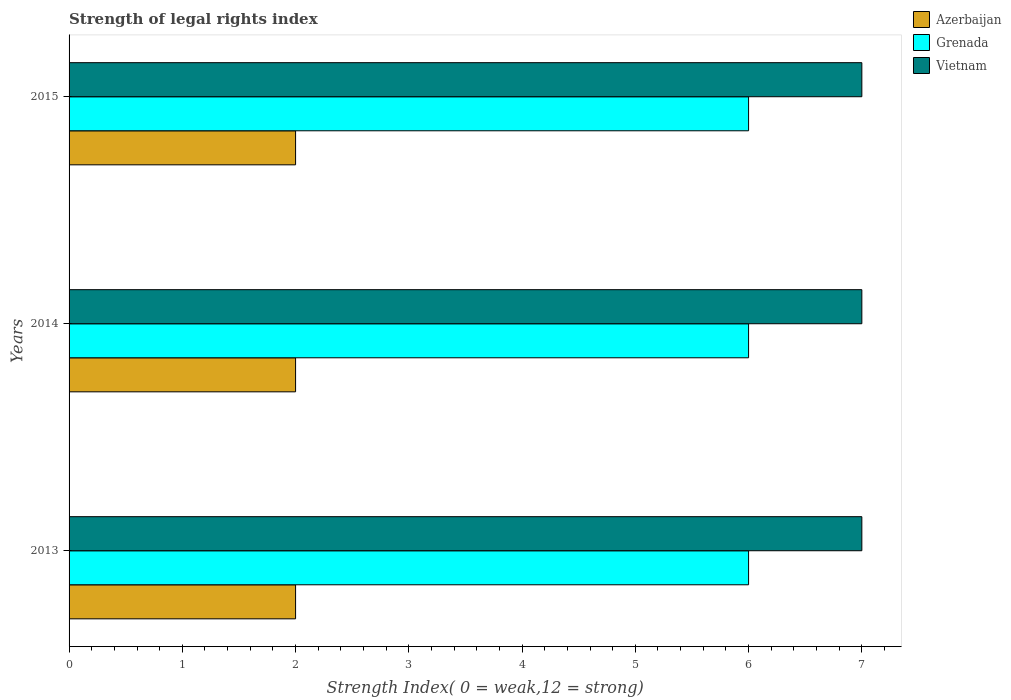How many different coloured bars are there?
Your answer should be compact. 3. Are the number of bars per tick equal to the number of legend labels?
Your answer should be compact. Yes. How many bars are there on the 3rd tick from the top?
Provide a short and direct response. 3. What is the label of the 2nd group of bars from the top?
Make the answer very short. 2014. What is the strength index in Grenada in 2013?
Your response must be concise. 6. In which year was the strength index in Azerbaijan minimum?
Your response must be concise. 2013. What is the total strength index in Grenada in the graph?
Offer a terse response. 18. What is the difference between the strength index in Azerbaijan in 2014 and the strength index in Vietnam in 2015?
Provide a succinct answer. -5. What is the average strength index in Grenada per year?
Offer a very short reply. 6. In the year 2014, what is the difference between the strength index in Azerbaijan and strength index in Grenada?
Your answer should be very brief. -4. What is the ratio of the strength index in Vietnam in 2013 to that in 2014?
Offer a very short reply. 1. Is the strength index in Grenada in 2013 less than that in 2014?
Provide a short and direct response. No. Is the difference between the strength index in Azerbaijan in 2013 and 2014 greater than the difference between the strength index in Grenada in 2013 and 2014?
Give a very brief answer. No. What does the 3rd bar from the top in 2013 represents?
Your answer should be very brief. Azerbaijan. What does the 2nd bar from the bottom in 2013 represents?
Provide a succinct answer. Grenada. Are all the bars in the graph horizontal?
Your answer should be very brief. Yes. How many years are there in the graph?
Your answer should be very brief. 3. What is the difference between two consecutive major ticks on the X-axis?
Provide a succinct answer. 1. How are the legend labels stacked?
Provide a short and direct response. Vertical. What is the title of the graph?
Your response must be concise. Strength of legal rights index. What is the label or title of the X-axis?
Your response must be concise. Strength Index( 0 = weak,12 = strong). What is the Strength Index( 0 = weak,12 = strong) in Azerbaijan in 2013?
Your answer should be compact. 2. What is the Strength Index( 0 = weak,12 = strong) of Grenada in 2013?
Your answer should be very brief. 6. What is the Strength Index( 0 = weak,12 = strong) in Vietnam in 2014?
Offer a very short reply. 7. What is the Strength Index( 0 = weak,12 = strong) in Grenada in 2015?
Make the answer very short. 6. What is the Strength Index( 0 = weak,12 = strong) in Vietnam in 2015?
Make the answer very short. 7. Across all years, what is the maximum Strength Index( 0 = weak,12 = strong) of Azerbaijan?
Your answer should be very brief. 2. Across all years, what is the maximum Strength Index( 0 = weak,12 = strong) of Grenada?
Give a very brief answer. 6. Across all years, what is the maximum Strength Index( 0 = weak,12 = strong) in Vietnam?
Provide a succinct answer. 7. Across all years, what is the minimum Strength Index( 0 = weak,12 = strong) of Grenada?
Make the answer very short. 6. What is the total Strength Index( 0 = weak,12 = strong) in Azerbaijan in the graph?
Offer a very short reply. 6. What is the difference between the Strength Index( 0 = weak,12 = strong) of Vietnam in 2013 and that in 2014?
Provide a short and direct response. 0. What is the difference between the Strength Index( 0 = weak,12 = strong) in Azerbaijan in 2014 and that in 2015?
Give a very brief answer. 0. What is the difference between the Strength Index( 0 = weak,12 = strong) of Grenada in 2014 and that in 2015?
Give a very brief answer. 0. What is the difference between the Strength Index( 0 = weak,12 = strong) in Vietnam in 2014 and that in 2015?
Your response must be concise. 0. What is the difference between the Strength Index( 0 = weak,12 = strong) in Grenada in 2013 and the Strength Index( 0 = weak,12 = strong) in Vietnam in 2014?
Your response must be concise. -1. What is the difference between the Strength Index( 0 = weak,12 = strong) in Azerbaijan in 2013 and the Strength Index( 0 = weak,12 = strong) in Grenada in 2015?
Provide a succinct answer. -4. What is the difference between the Strength Index( 0 = weak,12 = strong) in Azerbaijan in 2013 and the Strength Index( 0 = weak,12 = strong) in Vietnam in 2015?
Provide a short and direct response. -5. What is the average Strength Index( 0 = weak,12 = strong) in Grenada per year?
Your response must be concise. 6. In the year 2013, what is the difference between the Strength Index( 0 = weak,12 = strong) in Azerbaijan and Strength Index( 0 = weak,12 = strong) in Grenada?
Provide a succinct answer. -4. In the year 2013, what is the difference between the Strength Index( 0 = weak,12 = strong) of Azerbaijan and Strength Index( 0 = weak,12 = strong) of Vietnam?
Provide a succinct answer. -5. In the year 2013, what is the difference between the Strength Index( 0 = weak,12 = strong) in Grenada and Strength Index( 0 = weak,12 = strong) in Vietnam?
Give a very brief answer. -1. In the year 2014, what is the difference between the Strength Index( 0 = weak,12 = strong) in Azerbaijan and Strength Index( 0 = weak,12 = strong) in Vietnam?
Your response must be concise. -5. In the year 2014, what is the difference between the Strength Index( 0 = weak,12 = strong) of Grenada and Strength Index( 0 = weak,12 = strong) of Vietnam?
Your answer should be compact. -1. In the year 2015, what is the difference between the Strength Index( 0 = weak,12 = strong) in Azerbaijan and Strength Index( 0 = weak,12 = strong) in Vietnam?
Keep it short and to the point. -5. In the year 2015, what is the difference between the Strength Index( 0 = weak,12 = strong) in Grenada and Strength Index( 0 = weak,12 = strong) in Vietnam?
Offer a terse response. -1. What is the ratio of the Strength Index( 0 = weak,12 = strong) of Azerbaijan in 2013 to that in 2014?
Your answer should be compact. 1. What is the ratio of the Strength Index( 0 = weak,12 = strong) in Azerbaijan in 2013 to that in 2015?
Give a very brief answer. 1. What is the ratio of the Strength Index( 0 = weak,12 = strong) of Vietnam in 2013 to that in 2015?
Provide a short and direct response. 1. What is the ratio of the Strength Index( 0 = weak,12 = strong) in Azerbaijan in 2014 to that in 2015?
Give a very brief answer. 1. What is the ratio of the Strength Index( 0 = weak,12 = strong) of Grenada in 2014 to that in 2015?
Give a very brief answer. 1. What is the difference between the highest and the second highest Strength Index( 0 = weak,12 = strong) in Grenada?
Provide a succinct answer. 0. What is the difference between the highest and the lowest Strength Index( 0 = weak,12 = strong) in Azerbaijan?
Provide a succinct answer. 0. What is the difference between the highest and the lowest Strength Index( 0 = weak,12 = strong) in Grenada?
Keep it short and to the point. 0. What is the difference between the highest and the lowest Strength Index( 0 = weak,12 = strong) of Vietnam?
Provide a short and direct response. 0. 